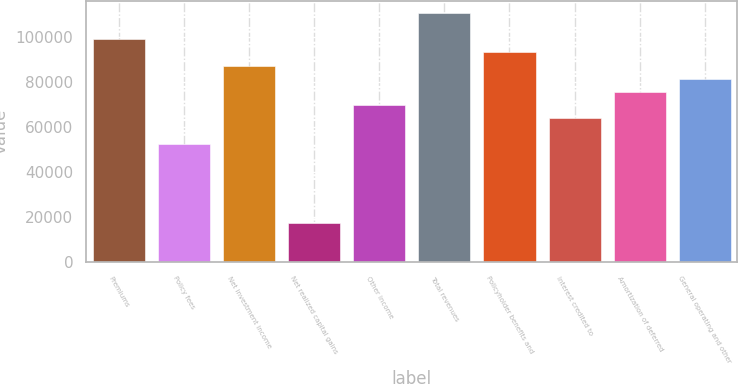Convert chart. <chart><loc_0><loc_0><loc_500><loc_500><bar_chart><fcel>Premiums<fcel>Policy fees<fcel>Net investment income<fcel>Net realized capital gains<fcel>Other income<fcel>Total revenues<fcel>Policyholder benefits and<fcel>Interest credited to<fcel>Amortization of deferred<fcel>General operating and other<nl><fcel>99148.2<fcel>52495.4<fcel>87485<fcel>17505.8<fcel>69990.2<fcel>110811<fcel>93316.6<fcel>64158.6<fcel>75821.8<fcel>81653.4<nl></chart> 